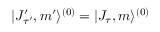<formula> <loc_0><loc_0><loc_500><loc_500>| J _ { \tau ^ { \prime } } ^ { \prime } , m ^ { \prime } \rangle ^ { ( 0 ) } = | J _ { \tau } , m \rangle ^ { ( 0 ) }</formula> 